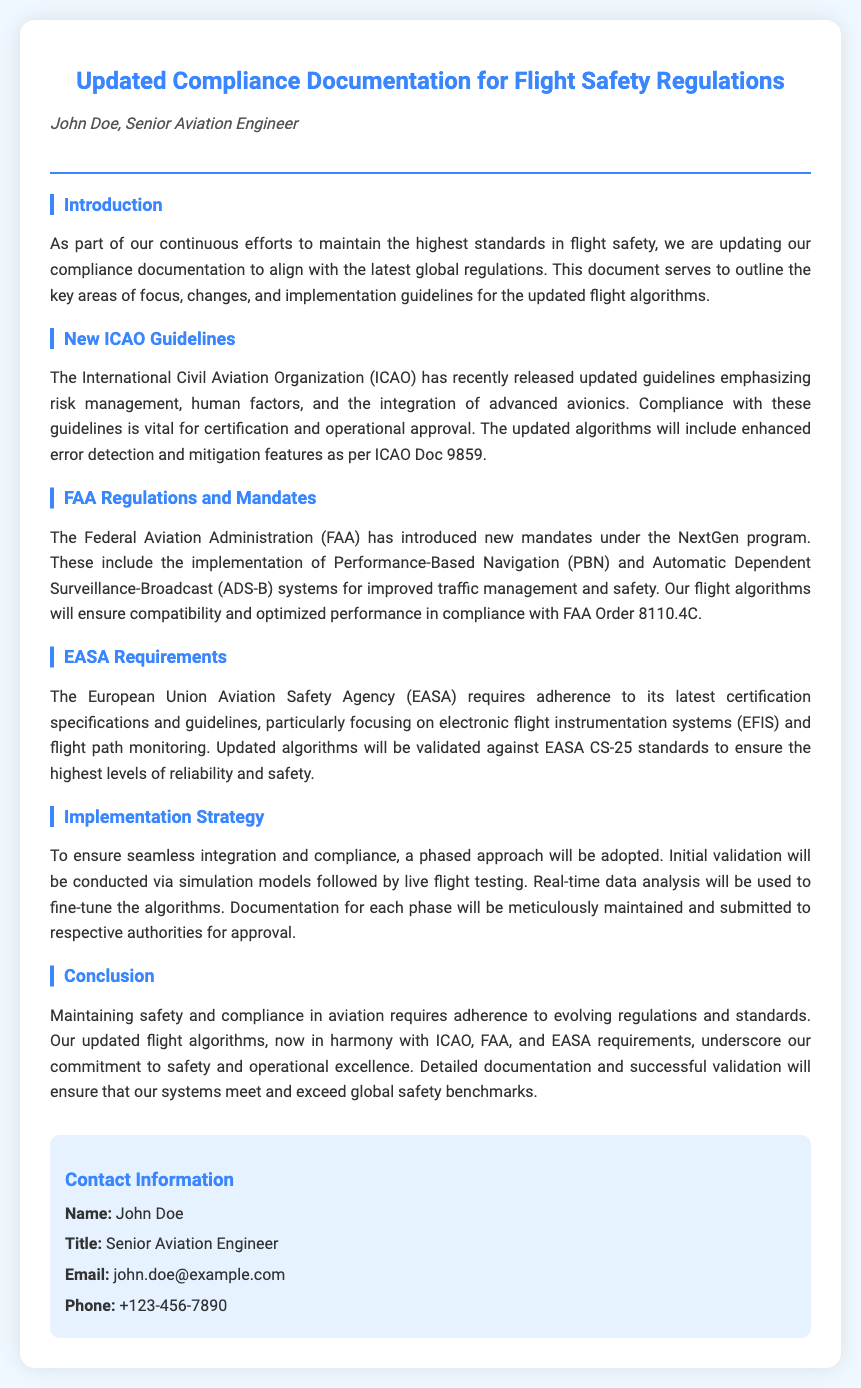what is the title of the document? The title of the document is presented prominently at the top.
Answer: Updated Compliance Documentation for Flight Safety Regulations who is the author of the document? The author's name is mentioned under the title.
Answer: John Doe which organization's guidelines are emphasized in the document? The document highlights the importance of adhering to international regulations issued by an established body.
Answer: ICAO what system is introduced under FAA's NextGen program? The document refers to a specific system aimed at improving traffic management and safety.
Answer: ADS-B what is the EASA certification specification mentioned? The document specifies a standard that the algorithms will be validated against.
Answer: EASA CS-25 what approach will be adopted for implementing the updates? The strategy for ensuring compliance and integration is outlined in the document.
Answer: Phased approach which type of testing will be performed before live flight testing? The initial method of validation is noted in the implementation strategy section.
Answer: Simulation models what is John Doe's email address? The contact information section includes the email address for inquiries.
Answer: john.doe@example.com 